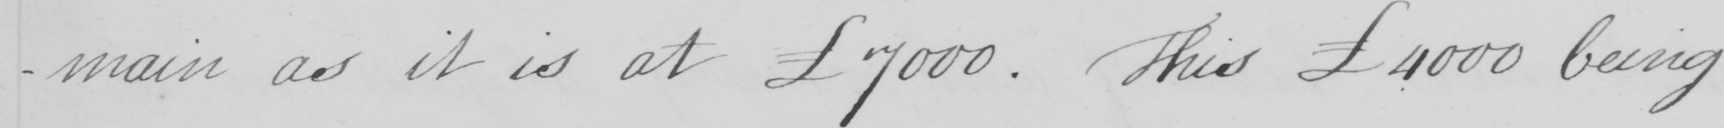Transcribe the text shown in this historical manuscript line. -main as it is at £7000 . This £4000 being 